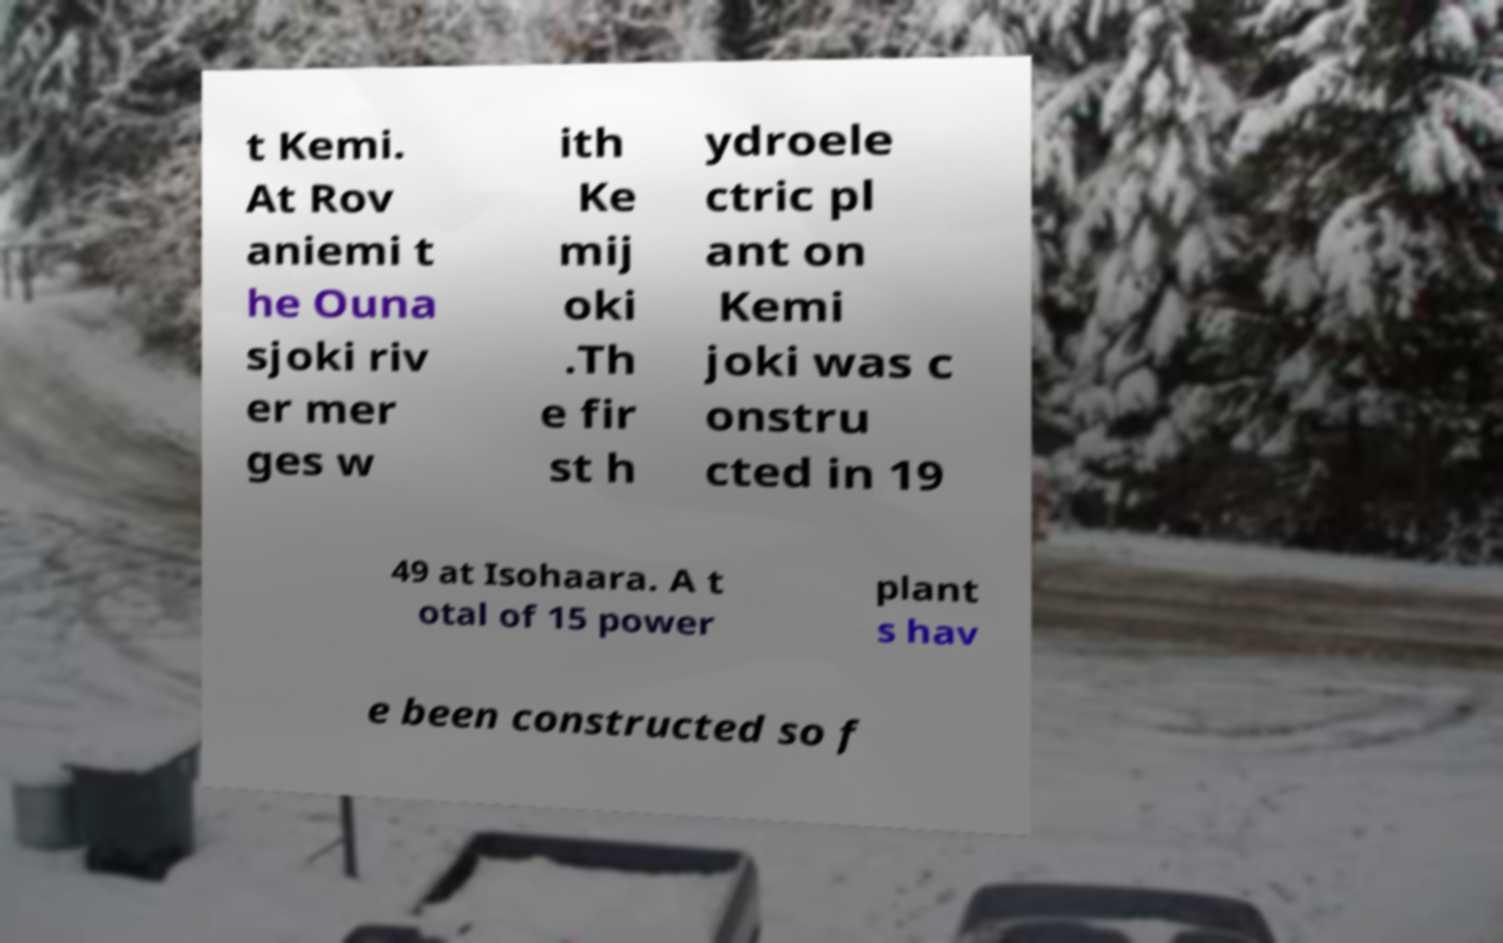There's text embedded in this image that I need extracted. Can you transcribe it verbatim? t Kemi. At Rov aniemi t he Ouna sjoki riv er mer ges w ith Ke mij oki .Th e fir st h ydroele ctric pl ant on Kemi joki was c onstru cted in 19 49 at Isohaara. A t otal of 15 power plant s hav e been constructed so f 